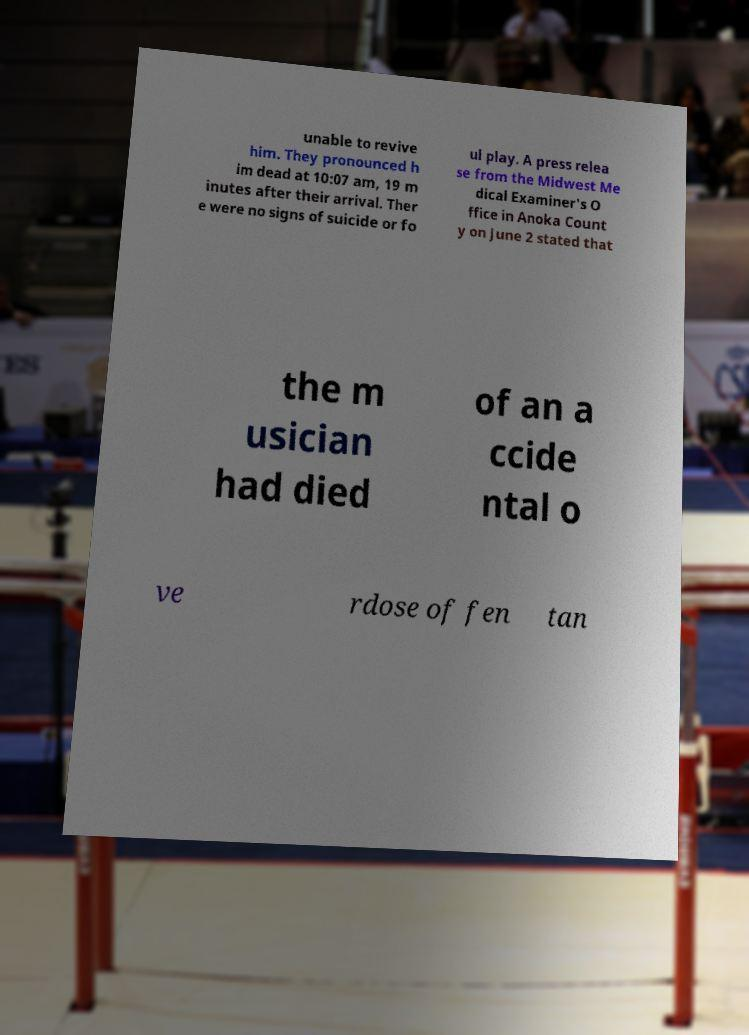Please identify and transcribe the text found in this image. unable to revive him. They pronounced h im dead at 10:07 am, 19 m inutes after their arrival. Ther e were no signs of suicide or fo ul play. A press relea se from the Midwest Me dical Examiner's O ffice in Anoka Count y on June 2 stated that the m usician had died of an a ccide ntal o ve rdose of fen tan 